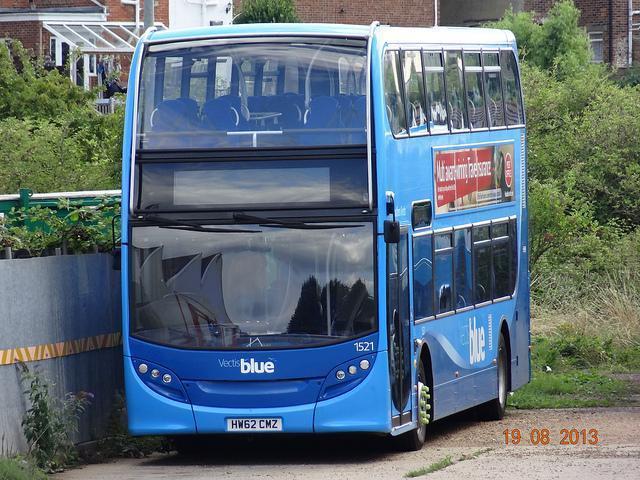How many levels is the bus?
Give a very brief answer. 2. 